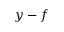Convert formula to latex. <formula><loc_0><loc_0><loc_500><loc_500>y - f</formula> 